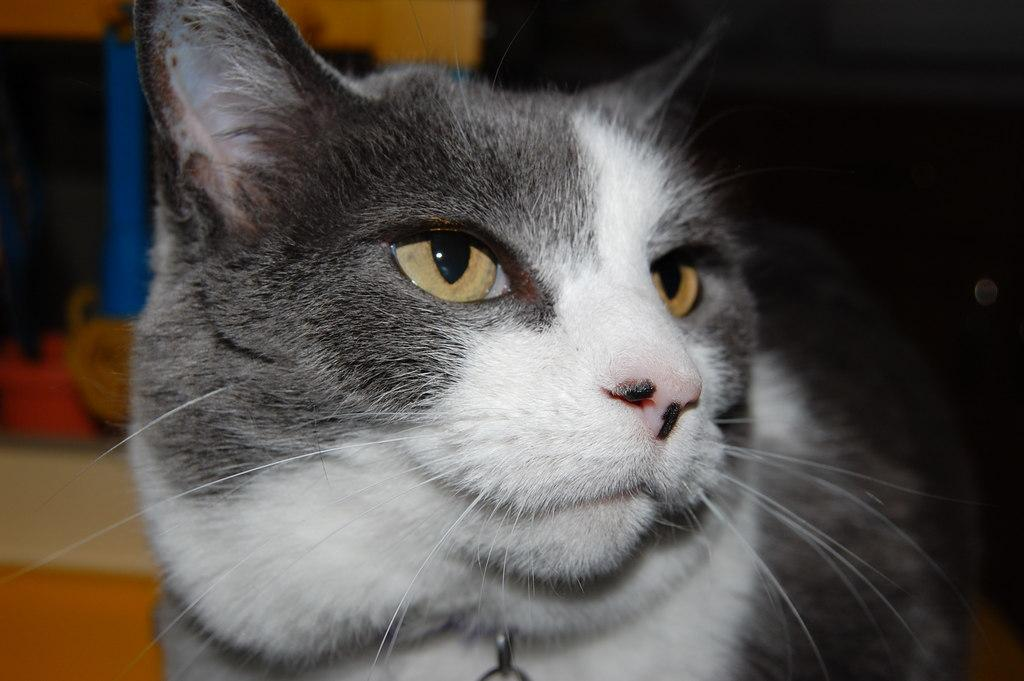What is the main subject in the foreground of the image? There is a cat in the foreground of the image. What can be seen in the background of the image? There are objects in the background of the image. How many clovers can be seen growing in the image? There are no clovers present in the image. What type of square structure can be seen in the background of the image? There is no square structure visible in the image. 